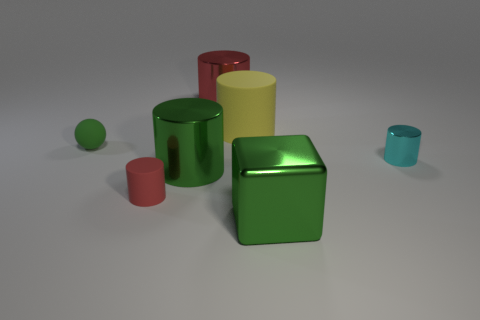Subtract all yellow matte cylinders. How many cylinders are left? 4 Add 3 tiny brown matte cylinders. How many objects exist? 10 Subtract all red cylinders. How many cylinders are left? 3 Subtract all red blocks. How many red cylinders are left? 2 Add 5 small matte objects. How many small matte objects are left? 7 Add 3 small brown shiny blocks. How many small brown shiny blocks exist? 3 Subtract 0 gray spheres. How many objects are left? 7 Subtract all cylinders. How many objects are left? 2 Subtract 4 cylinders. How many cylinders are left? 1 Subtract all green cylinders. Subtract all cyan spheres. How many cylinders are left? 4 